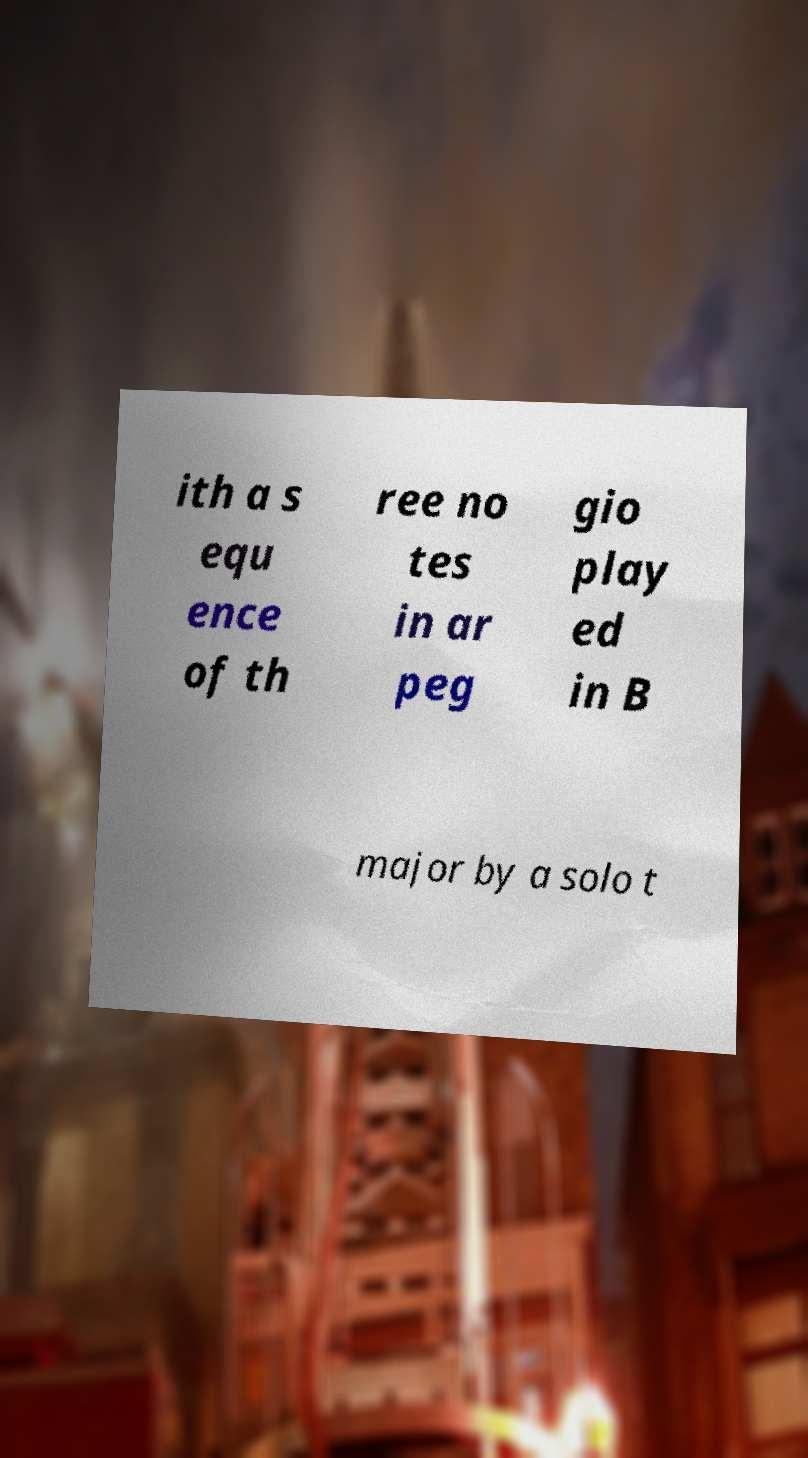Please read and relay the text visible in this image. What does it say? ith a s equ ence of th ree no tes in ar peg gio play ed in B major by a solo t 